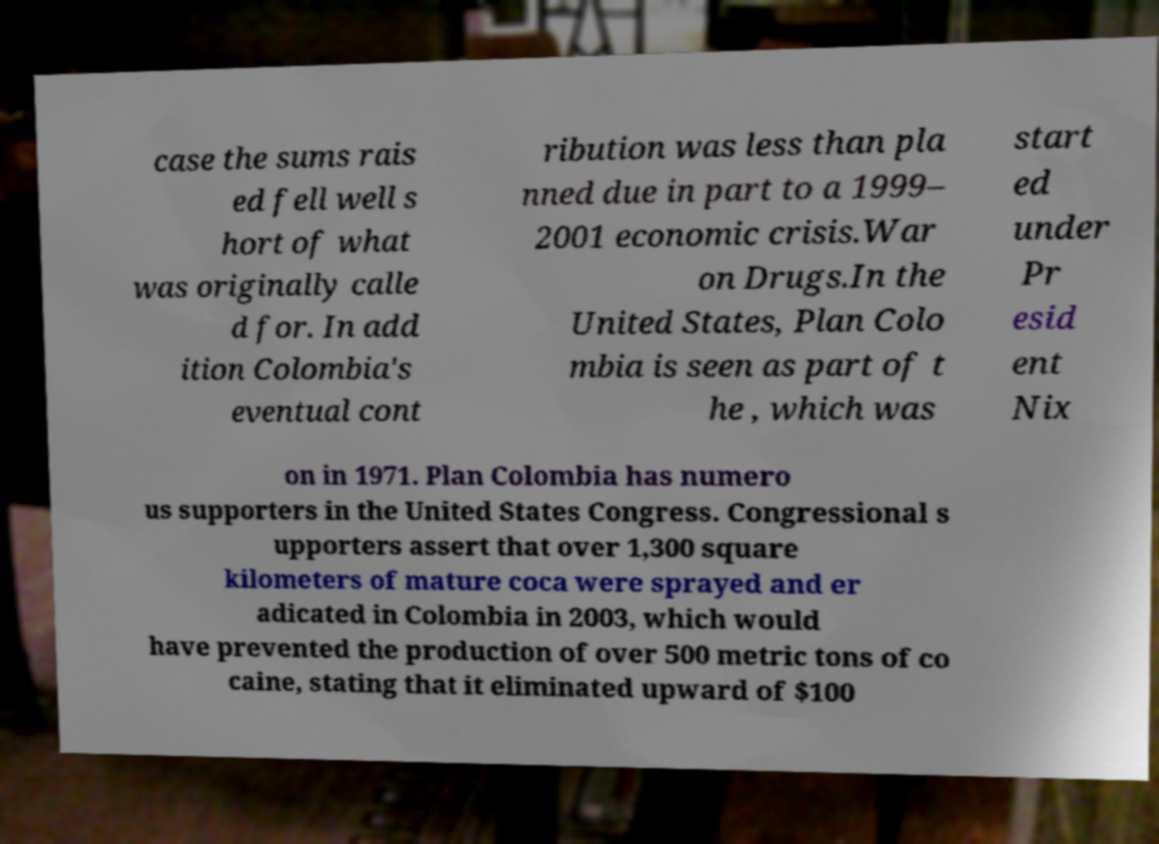Could you assist in decoding the text presented in this image and type it out clearly? case the sums rais ed fell well s hort of what was originally calle d for. In add ition Colombia's eventual cont ribution was less than pla nned due in part to a 1999– 2001 economic crisis.War on Drugs.In the United States, Plan Colo mbia is seen as part of t he , which was start ed under Pr esid ent Nix on in 1971. Plan Colombia has numero us supporters in the United States Congress. Congressional s upporters assert that over 1,300 square kilometers of mature coca were sprayed and er adicated in Colombia in 2003, which would have prevented the production of over 500 metric tons of co caine, stating that it eliminated upward of $100 